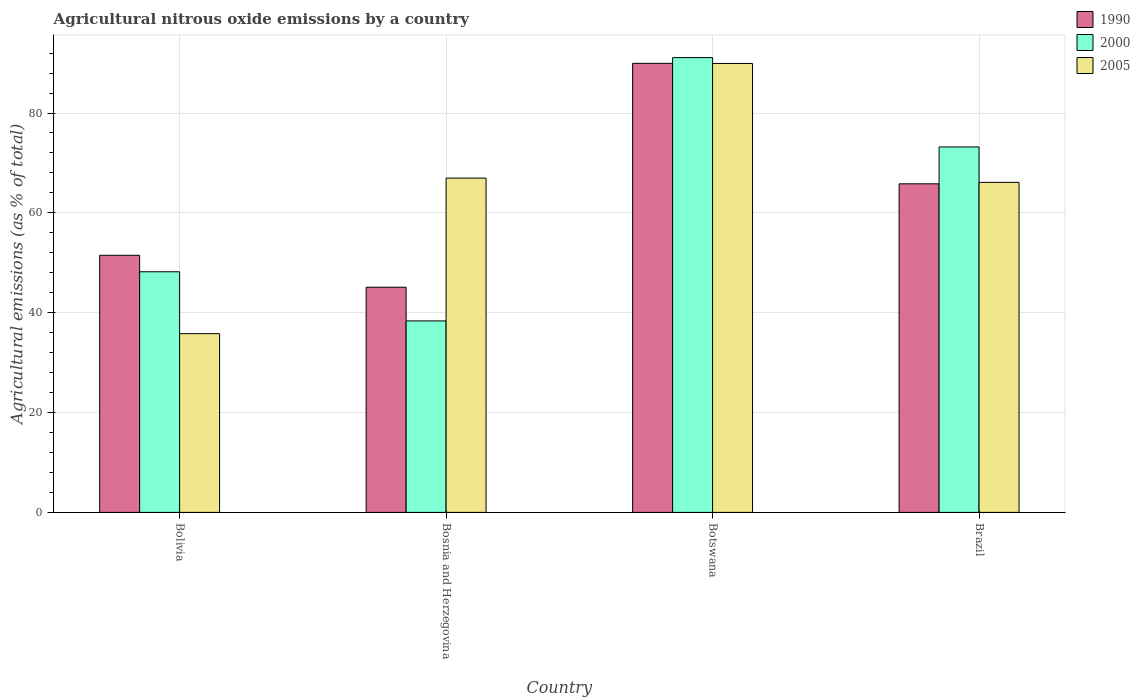How many different coloured bars are there?
Provide a short and direct response. 3. How many groups of bars are there?
Offer a terse response. 4. Are the number of bars per tick equal to the number of legend labels?
Offer a very short reply. Yes. Are the number of bars on each tick of the X-axis equal?
Ensure brevity in your answer.  Yes. How many bars are there on the 3rd tick from the left?
Keep it short and to the point. 3. How many bars are there on the 2nd tick from the right?
Ensure brevity in your answer.  3. What is the amount of agricultural nitrous oxide emitted in 1990 in Brazil?
Make the answer very short. 65.82. Across all countries, what is the maximum amount of agricultural nitrous oxide emitted in 2000?
Offer a very short reply. 91.1. Across all countries, what is the minimum amount of agricultural nitrous oxide emitted in 2005?
Provide a succinct answer. 35.8. In which country was the amount of agricultural nitrous oxide emitted in 2005 maximum?
Keep it short and to the point. Botswana. In which country was the amount of agricultural nitrous oxide emitted in 1990 minimum?
Offer a terse response. Bosnia and Herzegovina. What is the total amount of agricultural nitrous oxide emitted in 2000 in the graph?
Your answer should be very brief. 250.86. What is the difference between the amount of agricultural nitrous oxide emitted in 2005 in Bosnia and Herzegovina and that in Botswana?
Your answer should be compact. -22.96. What is the difference between the amount of agricultural nitrous oxide emitted in 1990 in Brazil and the amount of agricultural nitrous oxide emitted in 2000 in Bolivia?
Provide a succinct answer. 17.62. What is the average amount of agricultural nitrous oxide emitted in 2005 per country?
Your response must be concise. 64.7. What is the difference between the amount of agricultural nitrous oxide emitted of/in 2005 and amount of agricultural nitrous oxide emitted of/in 1990 in Brazil?
Ensure brevity in your answer.  0.29. What is the ratio of the amount of agricultural nitrous oxide emitted in 2000 in Bosnia and Herzegovina to that in Botswana?
Provide a short and direct response. 0.42. Is the amount of agricultural nitrous oxide emitted in 1990 in Bolivia less than that in Brazil?
Make the answer very short. Yes. What is the difference between the highest and the second highest amount of agricultural nitrous oxide emitted in 2005?
Keep it short and to the point. 22.96. What is the difference between the highest and the lowest amount of agricultural nitrous oxide emitted in 2005?
Give a very brief answer. 54.12. In how many countries, is the amount of agricultural nitrous oxide emitted in 2005 greater than the average amount of agricultural nitrous oxide emitted in 2005 taken over all countries?
Your answer should be very brief. 3. Is the sum of the amount of agricultural nitrous oxide emitted in 2000 in Bosnia and Herzegovina and Brazil greater than the maximum amount of agricultural nitrous oxide emitted in 2005 across all countries?
Make the answer very short. Yes. What does the 2nd bar from the left in Brazil represents?
Provide a short and direct response. 2000. Are all the bars in the graph horizontal?
Provide a short and direct response. No. Does the graph contain grids?
Provide a short and direct response. Yes. How many legend labels are there?
Your response must be concise. 3. What is the title of the graph?
Provide a succinct answer. Agricultural nitrous oxide emissions by a country. Does "2002" appear as one of the legend labels in the graph?
Offer a very short reply. No. What is the label or title of the X-axis?
Ensure brevity in your answer.  Country. What is the label or title of the Y-axis?
Offer a terse response. Agricultural emissions (as % of total). What is the Agricultural emissions (as % of total) of 1990 in Bolivia?
Your response must be concise. 51.5. What is the Agricultural emissions (as % of total) in 2000 in Bolivia?
Ensure brevity in your answer.  48.2. What is the Agricultural emissions (as % of total) in 2005 in Bolivia?
Make the answer very short. 35.8. What is the Agricultural emissions (as % of total) in 1990 in Bosnia and Herzegovina?
Provide a succinct answer. 45.1. What is the Agricultural emissions (as % of total) in 2000 in Bosnia and Herzegovina?
Keep it short and to the point. 38.36. What is the Agricultural emissions (as % of total) in 2005 in Bosnia and Herzegovina?
Offer a terse response. 66.97. What is the Agricultural emissions (as % of total) of 1990 in Botswana?
Offer a terse response. 89.96. What is the Agricultural emissions (as % of total) in 2000 in Botswana?
Offer a terse response. 91.1. What is the Agricultural emissions (as % of total) in 2005 in Botswana?
Provide a short and direct response. 89.93. What is the Agricultural emissions (as % of total) of 1990 in Brazil?
Make the answer very short. 65.82. What is the Agricultural emissions (as % of total) in 2000 in Brazil?
Give a very brief answer. 73.21. What is the Agricultural emissions (as % of total) of 2005 in Brazil?
Offer a very short reply. 66.11. Across all countries, what is the maximum Agricultural emissions (as % of total) of 1990?
Your answer should be compact. 89.96. Across all countries, what is the maximum Agricultural emissions (as % of total) in 2000?
Make the answer very short. 91.1. Across all countries, what is the maximum Agricultural emissions (as % of total) in 2005?
Your response must be concise. 89.93. Across all countries, what is the minimum Agricultural emissions (as % of total) in 1990?
Make the answer very short. 45.1. Across all countries, what is the minimum Agricultural emissions (as % of total) in 2000?
Your response must be concise. 38.36. Across all countries, what is the minimum Agricultural emissions (as % of total) of 2005?
Your answer should be very brief. 35.8. What is the total Agricultural emissions (as % of total) of 1990 in the graph?
Ensure brevity in your answer.  252.38. What is the total Agricultural emissions (as % of total) in 2000 in the graph?
Offer a terse response. 250.86. What is the total Agricultural emissions (as % of total) in 2005 in the graph?
Offer a terse response. 258.8. What is the difference between the Agricultural emissions (as % of total) of 1990 in Bolivia and that in Bosnia and Herzegovina?
Keep it short and to the point. 6.4. What is the difference between the Agricultural emissions (as % of total) of 2000 in Bolivia and that in Bosnia and Herzegovina?
Provide a short and direct response. 9.84. What is the difference between the Agricultural emissions (as % of total) of 2005 in Bolivia and that in Bosnia and Herzegovina?
Make the answer very short. -31.16. What is the difference between the Agricultural emissions (as % of total) in 1990 in Bolivia and that in Botswana?
Offer a very short reply. -38.45. What is the difference between the Agricultural emissions (as % of total) in 2000 in Bolivia and that in Botswana?
Provide a short and direct response. -42.9. What is the difference between the Agricultural emissions (as % of total) of 2005 in Bolivia and that in Botswana?
Provide a short and direct response. -54.12. What is the difference between the Agricultural emissions (as % of total) in 1990 in Bolivia and that in Brazil?
Ensure brevity in your answer.  -14.32. What is the difference between the Agricultural emissions (as % of total) in 2000 in Bolivia and that in Brazil?
Ensure brevity in your answer.  -25.01. What is the difference between the Agricultural emissions (as % of total) in 2005 in Bolivia and that in Brazil?
Provide a succinct answer. -30.3. What is the difference between the Agricultural emissions (as % of total) in 1990 in Bosnia and Herzegovina and that in Botswana?
Keep it short and to the point. -44.86. What is the difference between the Agricultural emissions (as % of total) of 2000 in Bosnia and Herzegovina and that in Botswana?
Make the answer very short. -52.74. What is the difference between the Agricultural emissions (as % of total) in 2005 in Bosnia and Herzegovina and that in Botswana?
Keep it short and to the point. -22.96. What is the difference between the Agricultural emissions (as % of total) in 1990 in Bosnia and Herzegovina and that in Brazil?
Offer a terse response. -20.72. What is the difference between the Agricultural emissions (as % of total) in 2000 in Bosnia and Herzegovina and that in Brazil?
Give a very brief answer. -34.85. What is the difference between the Agricultural emissions (as % of total) in 2005 in Bosnia and Herzegovina and that in Brazil?
Your answer should be very brief. 0.86. What is the difference between the Agricultural emissions (as % of total) of 1990 in Botswana and that in Brazil?
Provide a short and direct response. 24.14. What is the difference between the Agricultural emissions (as % of total) of 2000 in Botswana and that in Brazil?
Offer a terse response. 17.89. What is the difference between the Agricultural emissions (as % of total) of 2005 in Botswana and that in Brazil?
Your response must be concise. 23.82. What is the difference between the Agricultural emissions (as % of total) in 1990 in Bolivia and the Agricultural emissions (as % of total) in 2000 in Bosnia and Herzegovina?
Make the answer very short. 13.14. What is the difference between the Agricultural emissions (as % of total) of 1990 in Bolivia and the Agricultural emissions (as % of total) of 2005 in Bosnia and Herzegovina?
Provide a succinct answer. -15.47. What is the difference between the Agricultural emissions (as % of total) of 2000 in Bolivia and the Agricultural emissions (as % of total) of 2005 in Bosnia and Herzegovina?
Ensure brevity in your answer.  -18.77. What is the difference between the Agricultural emissions (as % of total) in 1990 in Bolivia and the Agricultural emissions (as % of total) in 2000 in Botswana?
Offer a terse response. -39.6. What is the difference between the Agricultural emissions (as % of total) of 1990 in Bolivia and the Agricultural emissions (as % of total) of 2005 in Botswana?
Ensure brevity in your answer.  -38.43. What is the difference between the Agricultural emissions (as % of total) in 2000 in Bolivia and the Agricultural emissions (as % of total) in 2005 in Botswana?
Ensure brevity in your answer.  -41.73. What is the difference between the Agricultural emissions (as % of total) of 1990 in Bolivia and the Agricultural emissions (as % of total) of 2000 in Brazil?
Give a very brief answer. -21.7. What is the difference between the Agricultural emissions (as % of total) in 1990 in Bolivia and the Agricultural emissions (as % of total) in 2005 in Brazil?
Keep it short and to the point. -14.6. What is the difference between the Agricultural emissions (as % of total) of 2000 in Bolivia and the Agricultural emissions (as % of total) of 2005 in Brazil?
Provide a succinct answer. -17.9. What is the difference between the Agricultural emissions (as % of total) in 1990 in Bosnia and Herzegovina and the Agricultural emissions (as % of total) in 2000 in Botswana?
Your answer should be very brief. -46. What is the difference between the Agricultural emissions (as % of total) in 1990 in Bosnia and Herzegovina and the Agricultural emissions (as % of total) in 2005 in Botswana?
Ensure brevity in your answer.  -44.83. What is the difference between the Agricultural emissions (as % of total) of 2000 in Bosnia and Herzegovina and the Agricultural emissions (as % of total) of 2005 in Botswana?
Your answer should be compact. -51.57. What is the difference between the Agricultural emissions (as % of total) of 1990 in Bosnia and Herzegovina and the Agricultural emissions (as % of total) of 2000 in Brazil?
Your answer should be very brief. -28.11. What is the difference between the Agricultural emissions (as % of total) of 1990 in Bosnia and Herzegovina and the Agricultural emissions (as % of total) of 2005 in Brazil?
Your response must be concise. -21. What is the difference between the Agricultural emissions (as % of total) in 2000 in Bosnia and Herzegovina and the Agricultural emissions (as % of total) in 2005 in Brazil?
Provide a short and direct response. -27.75. What is the difference between the Agricultural emissions (as % of total) of 1990 in Botswana and the Agricultural emissions (as % of total) of 2000 in Brazil?
Your response must be concise. 16.75. What is the difference between the Agricultural emissions (as % of total) in 1990 in Botswana and the Agricultural emissions (as % of total) in 2005 in Brazil?
Your response must be concise. 23.85. What is the difference between the Agricultural emissions (as % of total) in 2000 in Botswana and the Agricultural emissions (as % of total) in 2005 in Brazil?
Give a very brief answer. 24.99. What is the average Agricultural emissions (as % of total) in 1990 per country?
Provide a short and direct response. 63.09. What is the average Agricultural emissions (as % of total) of 2000 per country?
Provide a succinct answer. 62.72. What is the average Agricultural emissions (as % of total) in 2005 per country?
Your answer should be very brief. 64.7. What is the difference between the Agricultural emissions (as % of total) in 1990 and Agricultural emissions (as % of total) in 2000 in Bolivia?
Offer a very short reply. 3.3. What is the difference between the Agricultural emissions (as % of total) in 1990 and Agricultural emissions (as % of total) in 2005 in Bolivia?
Provide a short and direct response. 15.7. What is the difference between the Agricultural emissions (as % of total) in 2000 and Agricultural emissions (as % of total) in 2005 in Bolivia?
Provide a short and direct response. 12.4. What is the difference between the Agricultural emissions (as % of total) in 1990 and Agricultural emissions (as % of total) in 2000 in Bosnia and Herzegovina?
Your answer should be very brief. 6.74. What is the difference between the Agricultural emissions (as % of total) in 1990 and Agricultural emissions (as % of total) in 2005 in Bosnia and Herzegovina?
Offer a terse response. -21.87. What is the difference between the Agricultural emissions (as % of total) in 2000 and Agricultural emissions (as % of total) in 2005 in Bosnia and Herzegovina?
Ensure brevity in your answer.  -28.61. What is the difference between the Agricultural emissions (as % of total) of 1990 and Agricultural emissions (as % of total) of 2000 in Botswana?
Provide a succinct answer. -1.14. What is the difference between the Agricultural emissions (as % of total) in 1990 and Agricultural emissions (as % of total) in 2005 in Botswana?
Provide a succinct answer. 0.03. What is the difference between the Agricultural emissions (as % of total) in 2000 and Agricultural emissions (as % of total) in 2005 in Botswana?
Your answer should be compact. 1.17. What is the difference between the Agricultural emissions (as % of total) in 1990 and Agricultural emissions (as % of total) in 2000 in Brazil?
Provide a succinct answer. -7.39. What is the difference between the Agricultural emissions (as % of total) in 1990 and Agricultural emissions (as % of total) in 2005 in Brazil?
Offer a terse response. -0.29. What is the difference between the Agricultural emissions (as % of total) of 2000 and Agricultural emissions (as % of total) of 2005 in Brazil?
Your response must be concise. 7.1. What is the ratio of the Agricultural emissions (as % of total) of 1990 in Bolivia to that in Bosnia and Herzegovina?
Provide a succinct answer. 1.14. What is the ratio of the Agricultural emissions (as % of total) of 2000 in Bolivia to that in Bosnia and Herzegovina?
Give a very brief answer. 1.26. What is the ratio of the Agricultural emissions (as % of total) of 2005 in Bolivia to that in Bosnia and Herzegovina?
Give a very brief answer. 0.53. What is the ratio of the Agricultural emissions (as % of total) in 1990 in Bolivia to that in Botswana?
Your response must be concise. 0.57. What is the ratio of the Agricultural emissions (as % of total) of 2000 in Bolivia to that in Botswana?
Provide a short and direct response. 0.53. What is the ratio of the Agricultural emissions (as % of total) of 2005 in Bolivia to that in Botswana?
Make the answer very short. 0.4. What is the ratio of the Agricultural emissions (as % of total) in 1990 in Bolivia to that in Brazil?
Ensure brevity in your answer.  0.78. What is the ratio of the Agricultural emissions (as % of total) in 2000 in Bolivia to that in Brazil?
Your answer should be very brief. 0.66. What is the ratio of the Agricultural emissions (as % of total) of 2005 in Bolivia to that in Brazil?
Provide a succinct answer. 0.54. What is the ratio of the Agricultural emissions (as % of total) in 1990 in Bosnia and Herzegovina to that in Botswana?
Your answer should be compact. 0.5. What is the ratio of the Agricultural emissions (as % of total) in 2000 in Bosnia and Herzegovina to that in Botswana?
Give a very brief answer. 0.42. What is the ratio of the Agricultural emissions (as % of total) in 2005 in Bosnia and Herzegovina to that in Botswana?
Provide a succinct answer. 0.74. What is the ratio of the Agricultural emissions (as % of total) in 1990 in Bosnia and Herzegovina to that in Brazil?
Provide a short and direct response. 0.69. What is the ratio of the Agricultural emissions (as % of total) in 2000 in Bosnia and Herzegovina to that in Brazil?
Your response must be concise. 0.52. What is the ratio of the Agricultural emissions (as % of total) of 1990 in Botswana to that in Brazil?
Keep it short and to the point. 1.37. What is the ratio of the Agricultural emissions (as % of total) in 2000 in Botswana to that in Brazil?
Offer a very short reply. 1.24. What is the ratio of the Agricultural emissions (as % of total) in 2005 in Botswana to that in Brazil?
Make the answer very short. 1.36. What is the difference between the highest and the second highest Agricultural emissions (as % of total) of 1990?
Your answer should be very brief. 24.14. What is the difference between the highest and the second highest Agricultural emissions (as % of total) of 2000?
Ensure brevity in your answer.  17.89. What is the difference between the highest and the second highest Agricultural emissions (as % of total) in 2005?
Give a very brief answer. 22.96. What is the difference between the highest and the lowest Agricultural emissions (as % of total) in 1990?
Your answer should be compact. 44.86. What is the difference between the highest and the lowest Agricultural emissions (as % of total) of 2000?
Give a very brief answer. 52.74. What is the difference between the highest and the lowest Agricultural emissions (as % of total) in 2005?
Make the answer very short. 54.12. 